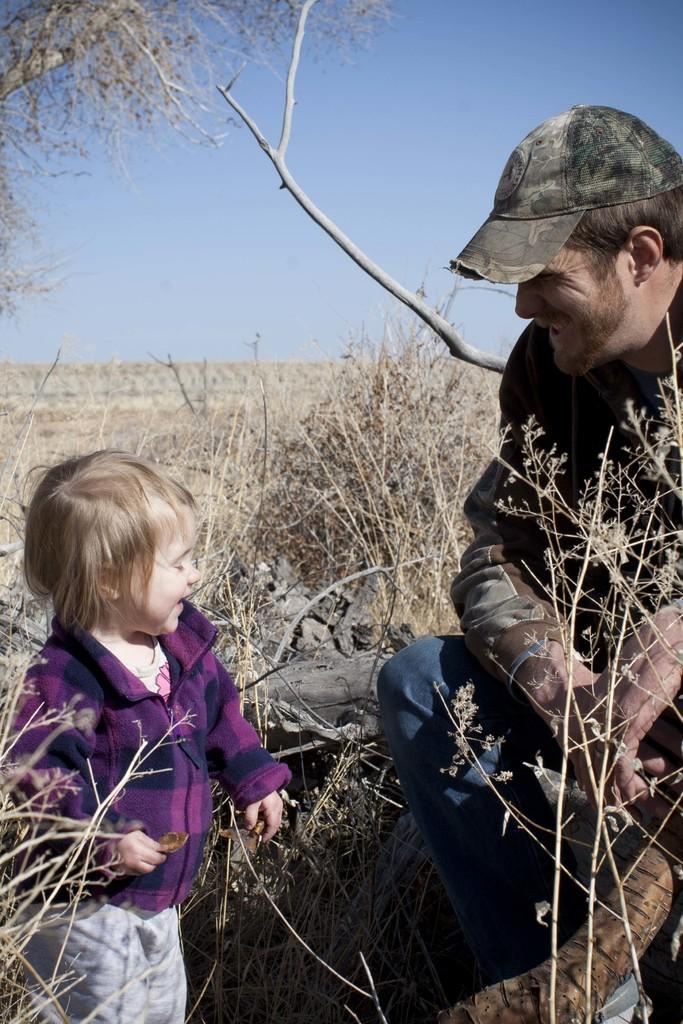Who is present in the image? There is a man and a child in the image. What are the man and the child doing? Both the man and the child are smiling in the image. What can be seen on the man's head? The man is wearing a cap in the image. What type of vegetation is visible in the image? There is dry grass and a dry tree in the image. What is the color of the sky in the image? The sky is pale blue in the image. What type of dirt can be seen on the snail in the image? There is no snail present in the image, so it is not possible to determine the type of dirt on it. What effect does the man's smile have on the child in the image? The provided facts do not mention any specific effect the man's smile has on the child, so we cannot answer this question definitively. 